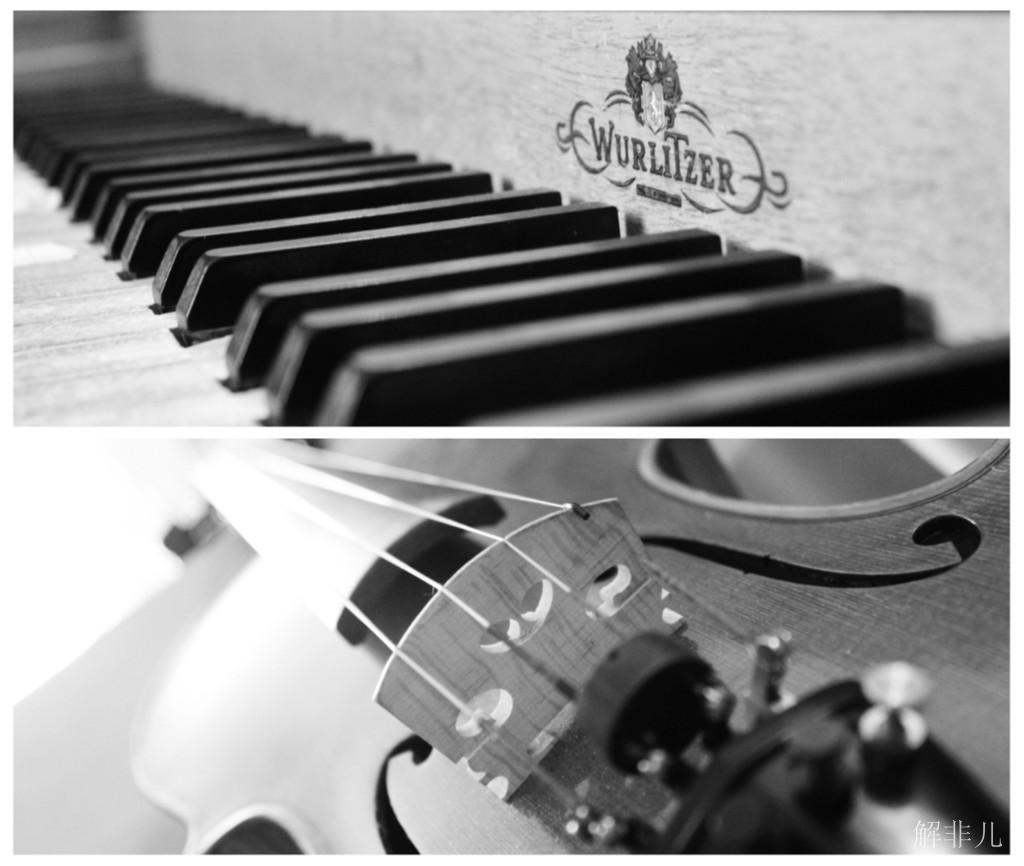What musical instruments are present in the image? There is a piano and a guitar in the image. Where are the musical instruments placed in the image? Both the piano and guitar are kept on a table. What type of scissors can be seen being used by the fireman in the image? There is no fireman or scissors present in the image; it features a piano and a guitar on a table. 